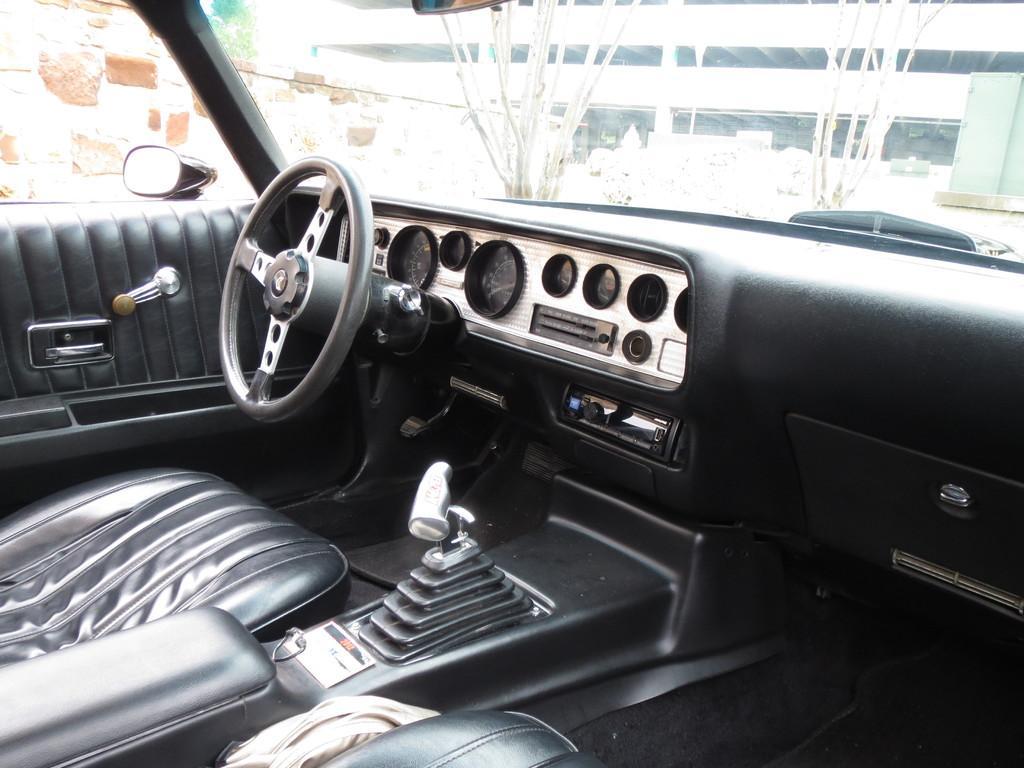Can you describe this image briefly? In this image we can see the interior of a car, one building, some trees, one wall and some objects on the surface. 